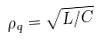Convert formula to latex. <formula><loc_0><loc_0><loc_500><loc_500>\rho _ { q } = \sqrt { L / C }</formula> 